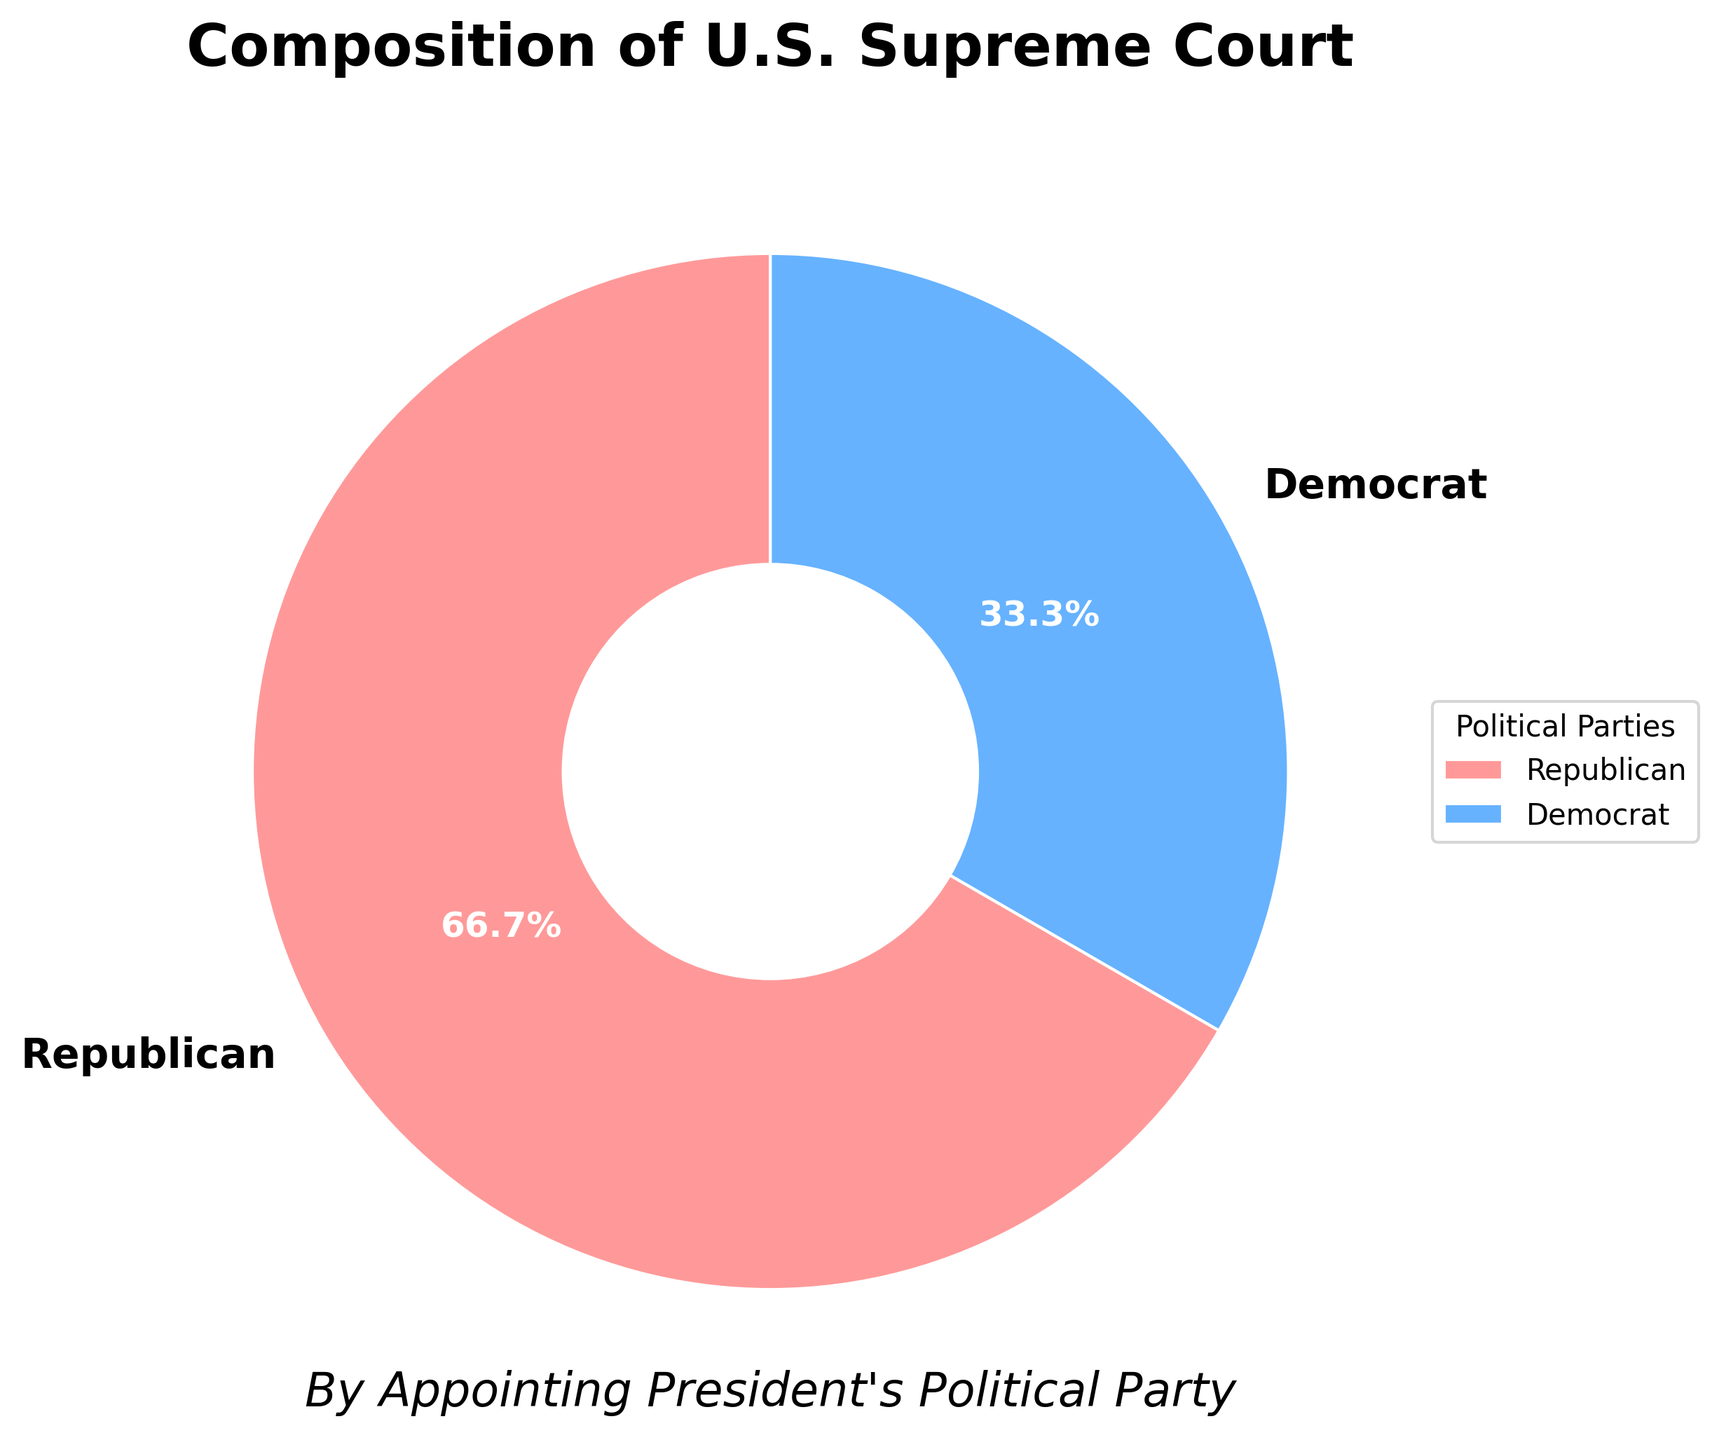What is the percentage of justices appointed by Republican presidents? Based on the pie chart, the segment representing Republican-appointed justices covers 66.7% of the pie.
Answer: 66.7% How many more justices were appointed by Republican presidents than Democrat presidents? The pie chart shows 6 justices appointed by Republican presidents and 3 by Democrat presidents. The difference is 6 - 3 = 3 justices.
Answer: 3 If two more justices were appointed by Democrat presidents, what would be the new percentage of Democrat-appointed justices? Adding two justices to the Democrat total gives 5 justices. The new total number of justices is 6 (Republican) + 5 (Democrat) = 11. The new percentage is (5/11) * 100 ≈ 45.5%.
Answer: 45.5% What is the ratio of justices appointed by Republican presidents to those appointed by Democrat presidents? The number of justices appointed by Republican presidents is 6, and by Democrat presidents is 3. The ratio is 6:3, which simplifies to 2:1.
Answer: 2:1 Which political party has appointed fewer justices to the Supreme Court? The pie chart shows that Democrat presidents have appointed 3 justices, whereas Republican presidents have appointed 6 justices. Democrats have appointed fewer justices.
Answer: Democrats Which color represents justices appointed by Republican presidents in the pie chart? By observing the pie chart, the color representing Republican-appointed justices is red.
Answer: Red If the total number of justices increased to 12 with an equal number of new justices appointed by both parties, what would be the percentage share of Republican-appointed justices? Adding one justice to each party yields 7 Republican and 4 Democrat justices, totaling 11 justices. The percentage for Republican justices is (7/11) * 100 ≈ 63.6%.
Answer: 63.6% What is the most noticeable visual attribute that distinguishes the two groups of justices in the chart? The most noticeable visual attribute is the color difference: red for Republican-appointed and blue for Democrat-appointed justices.
Answer: Color difference 